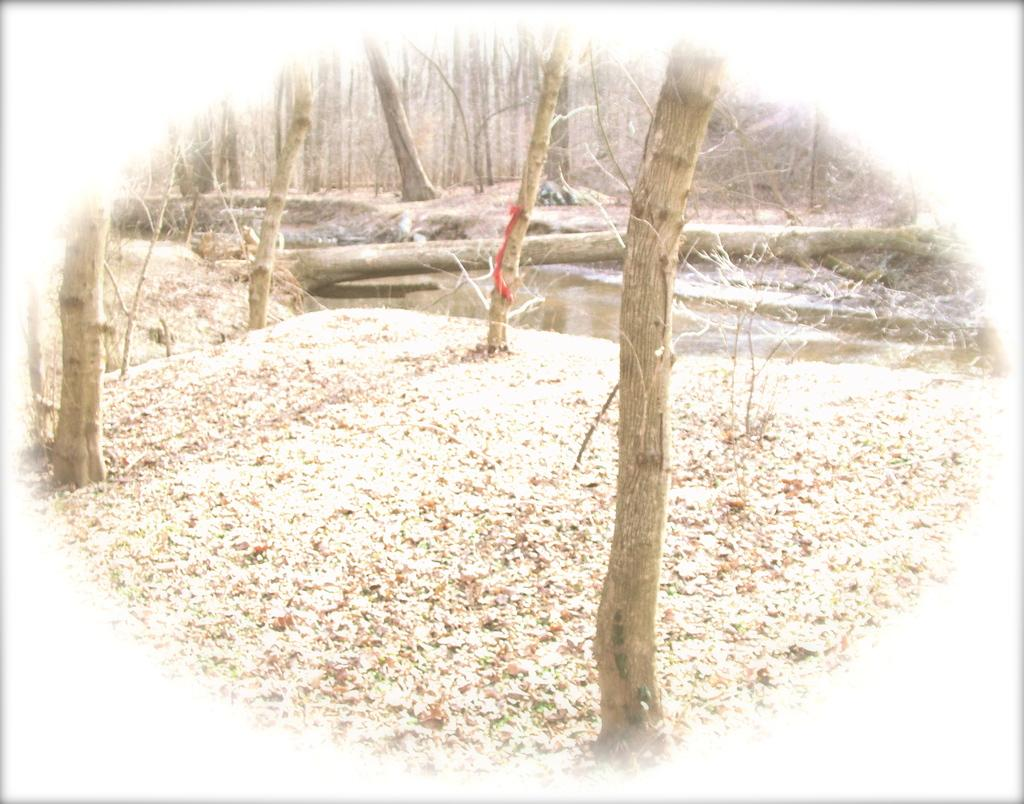What is the main element in the center of the image? There is water in the center of the image. What type of vegetation is present at the bottom of the image? There is dried grass at the bottom of the image. What can be seen in the background of the image? There are trees in the background of the image. What type of control does the minister have over the water in the image? There is no minister present in the image, and therefore no control over the water can be determined. 